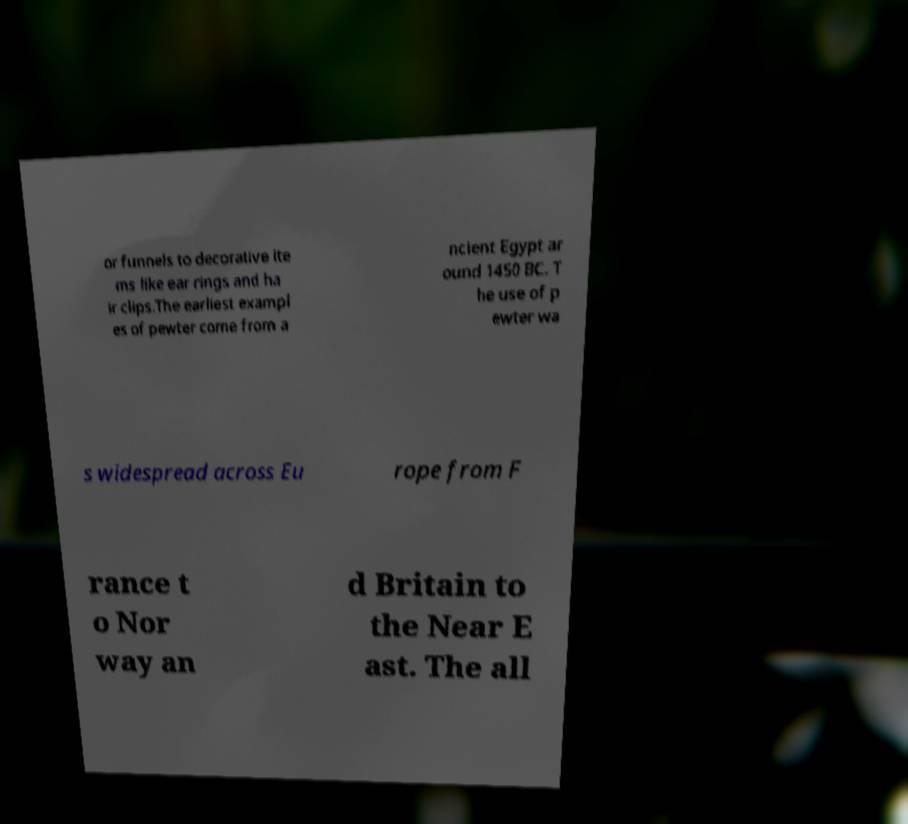Can you read and provide the text displayed in the image?This photo seems to have some interesting text. Can you extract and type it out for me? or funnels to decorative ite ms like ear rings and ha ir clips.The earliest exampl es of pewter come from a ncient Egypt ar ound 1450 BC. T he use of p ewter wa s widespread across Eu rope from F rance t o Nor way an d Britain to the Near E ast. The all 